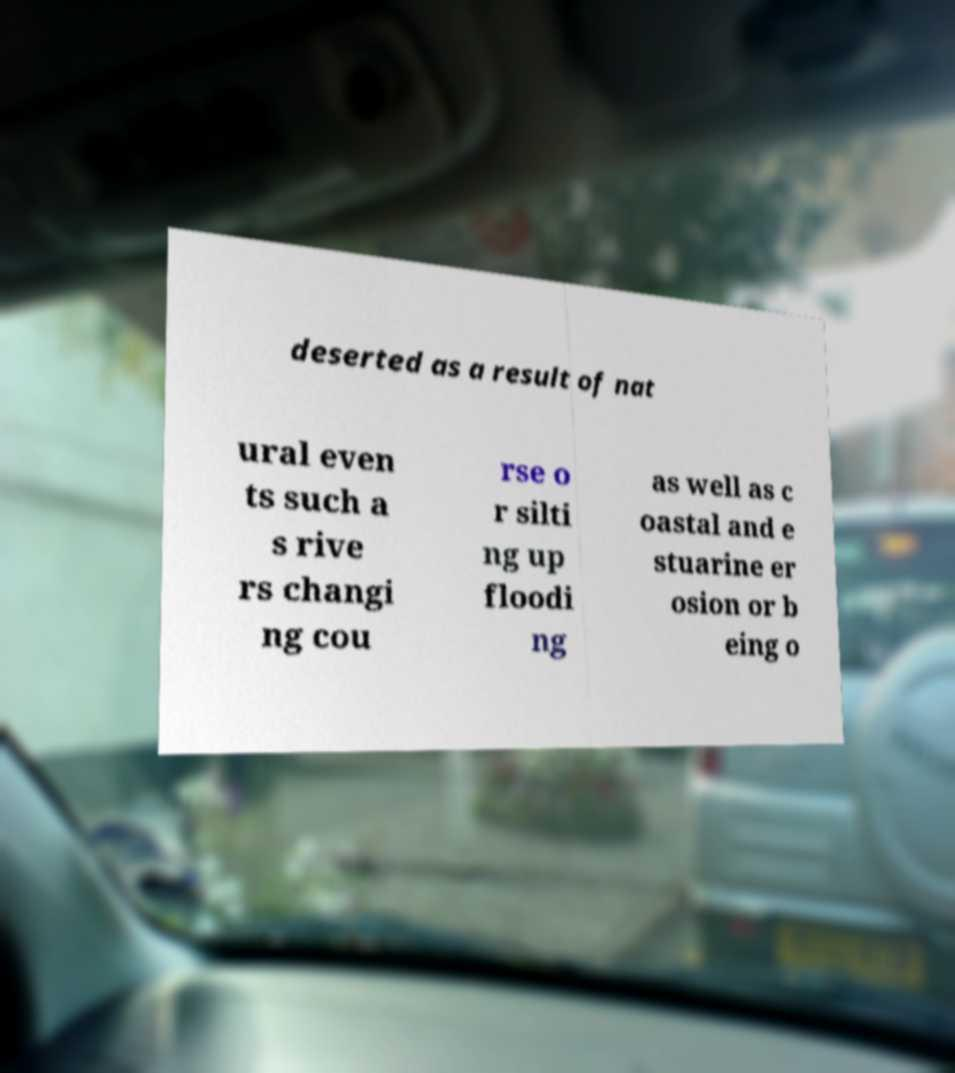Can you read and provide the text displayed in the image?This photo seems to have some interesting text. Can you extract and type it out for me? deserted as a result of nat ural even ts such a s rive rs changi ng cou rse o r silti ng up floodi ng as well as c oastal and e stuarine er osion or b eing o 